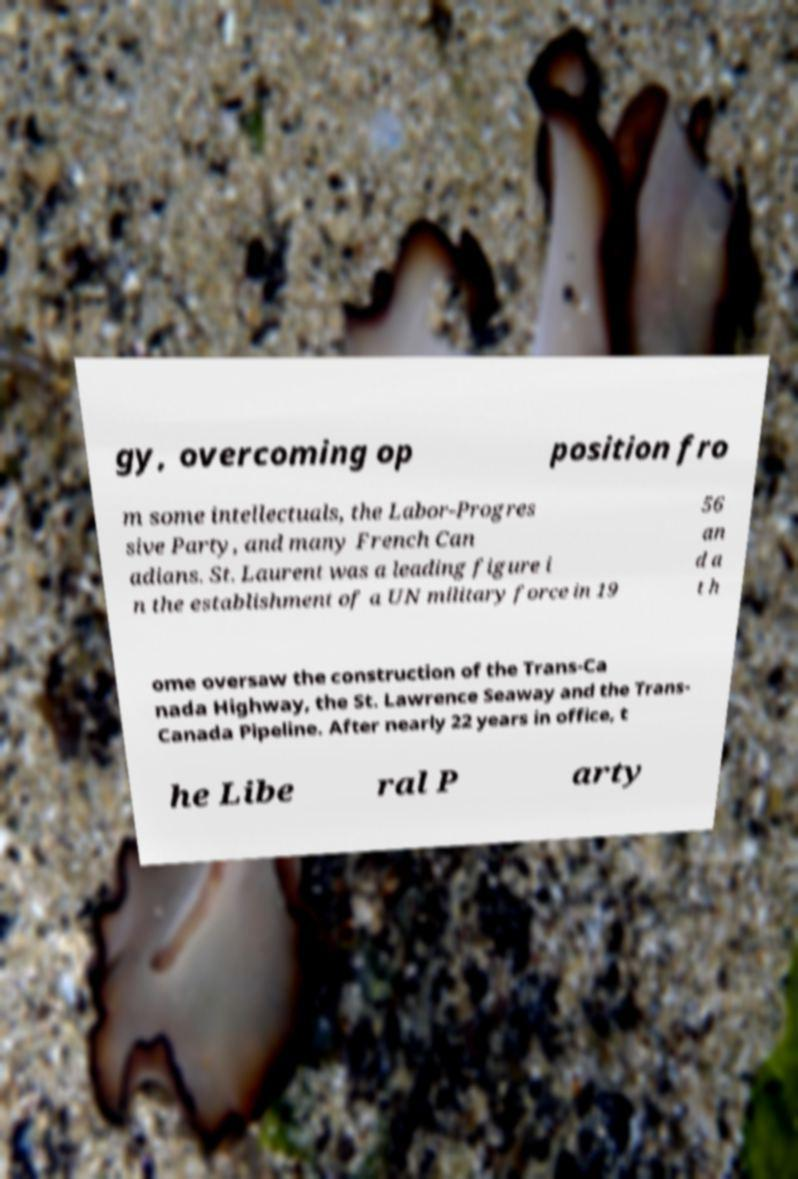Please read and relay the text visible in this image. What does it say? gy, overcoming op position fro m some intellectuals, the Labor-Progres sive Party, and many French Can adians. St. Laurent was a leading figure i n the establishment of a UN military force in 19 56 an d a t h ome oversaw the construction of the Trans-Ca nada Highway, the St. Lawrence Seaway and the Trans- Canada Pipeline. After nearly 22 years in office, t he Libe ral P arty 